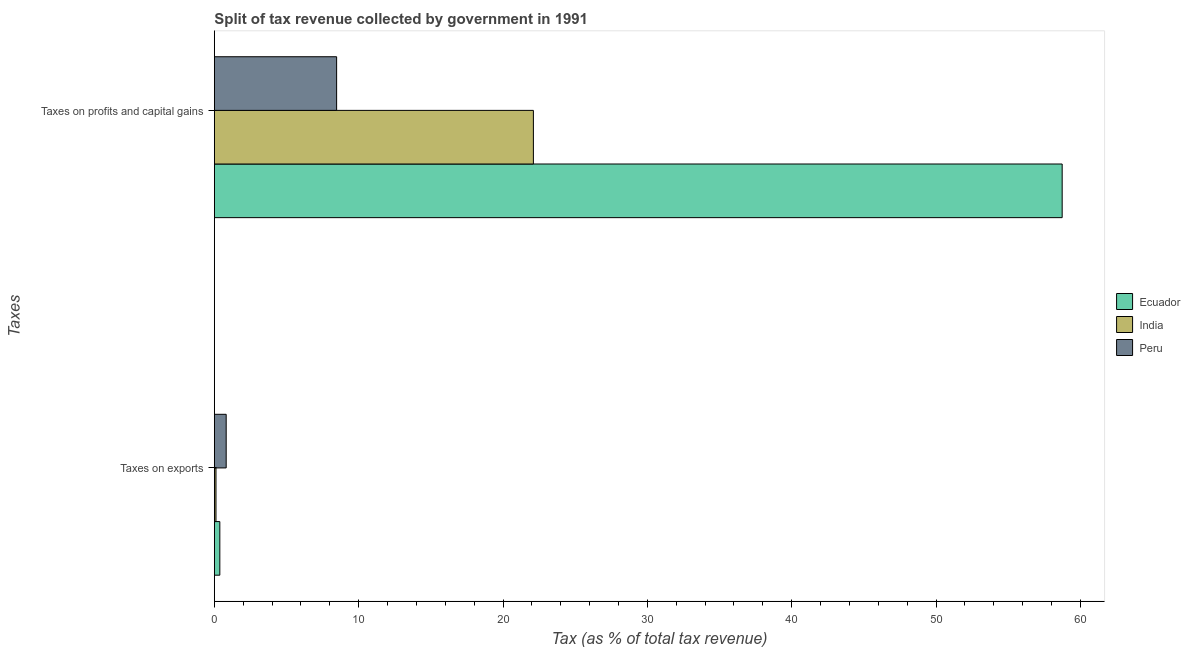How many different coloured bars are there?
Make the answer very short. 3. Are the number of bars per tick equal to the number of legend labels?
Make the answer very short. Yes. How many bars are there on the 1st tick from the top?
Keep it short and to the point. 3. What is the label of the 2nd group of bars from the top?
Your answer should be very brief. Taxes on exports. What is the percentage of revenue obtained from taxes on exports in Ecuador?
Offer a terse response. 0.38. Across all countries, what is the maximum percentage of revenue obtained from taxes on profits and capital gains?
Provide a succinct answer. 58.74. Across all countries, what is the minimum percentage of revenue obtained from taxes on profits and capital gains?
Offer a terse response. 8.47. In which country was the percentage of revenue obtained from taxes on profits and capital gains maximum?
Provide a short and direct response. Ecuador. What is the total percentage of revenue obtained from taxes on exports in the graph?
Your answer should be compact. 1.31. What is the difference between the percentage of revenue obtained from taxes on profits and capital gains in Peru and that in Ecuador?
Give a very brief answer. -50.27. What is the difference between the percentage of revenue obtained from taxes on profits and capital gains in Ecuador and the percentage of revenue obtained from taxes on exports in Peru?
Make the answer very short. 57.92. What is the average percentage of revenue obtained from taxes on exports per country?
Make the answer very short. 0.44. What is the difference between the percentage of revenue obtained from taxes on exports and percentage of revenue obtained from taxes on profits and capital gains in India?
Offer a very short reply. -21.99. In how many countries, is the percentage of revenue obtained from taxes on profits and capital gains greater than 30 %?
Provide a short and direct response. 1. What is the ratio of the percentage of revenue obtained from taxes on exports in Ecuador to that in India?
Provide a succinct answer. 3.37. What does the 1st bar from the top in Taxes on exports represents?
Keep it short and to the point. Peru. What does the 3rd bar from the bottom in Taxes on exports represents?
Your response must be concise. Peru. Are all the bars in the graph horizontal?
Provide a short and direct response. Yes. How many countries are there in the graph?
Your response must be concise. 3. Are the values on the major ticks of X-axis written in scientific E-notation?
Offer a terse response. No. Does the graph contain grids?
Your answer should be compact. No. Where does the legend appear in the graph?
Make the answer very short. Center right. How many legend labels are there?
Give a very brief answer. 3. How are the legend labels stacked?
Make the answer very short. Vertical. What is the title of the graph?
Make the answer very short. Split of tax revenue collected by government in 1991. What is the label or title of the X-axis?
Make the answer very short. Tax (as % of total tax revenue). What is the label or title of the Y-axis?
Provide a succinct answer. Taxes. What is the Tax (as % of total tax revenue) of Ecuador in Taxes on exports?
Provide a short and direct response. 0.38. What is the Tax (as % of total tax revenue) of India in Taxes on exports?
Give a very brief answer. 0.11. What is the Tax (as % of total tax revenue) of Peru in Taxes on exports?
Your answer should be very brief. 0.82. What is the Tax (as % of total tax revenue) in Ecuador in Taxes on profits and capital gains?
Keep it short and to the point. 58.74. What is the Tax (as % of total tax revenue) in India in Taxes on profits and capital gains?
Offer a terse response. 22.1. What is the Tax (as % of total tax revenue) of Peru in Taxes on profits and capital gains?
Your response must be concise. 8.47. Across all Taxes, what is the maximum Tax (as % of total tax revenue) in Ecuador?
Offer a terse response. 58.74. Across all Taxes, what is the maximum Tax (as % of total tax revenue) of India?
Ensure brevity in your answer.  22.1. Across all Taxes, what is the maximum Tax (as % of total tax revenue) of Peru?
Offer a terse response. 8.47. Across all Taxes, what is the minimum Tax (as % of total tax revenue) of Ecuador?
Keep it short and to the point. 0.38. Across all Taxes, what is the minimum Tax (as % of total tax revenue) in India?
Your response must be concise. 0.11. Across all Taxes, what is the minimum Tax (as % of total tax revenue) of Peru?
Your response must be concise. 0.82. What is the total Tax (as % of total tax revenue) in Ecuador in the graph?
Make the answer very short. 59.12. What is the total Tax (as % of total tax revenue) of India in the graph?
Make the answer very short. 22.22. What is the total Tax (as % of total tax revenue) in Peru in the graph?
Offer a very short reply. 9.29. What is the difference between the Tax (as % of total tax revenue) in Ecuador in Taxes on exports and that in Taxes on profits and capital gains?
Make the answer very short. -58.36. What is the difference between the Tax (as % of total tax revenue) of India in Taxes on exports and that in Taxes on profits and capital gains?
Your response must be concise. -21.99. What is the difference between the Tax (as % of total tax revenue) in Peru in Taxes on exports and that in Taxes on profits and capital gains?
Give a very brief answer. -7.65. What is the difference between the Tax (as % of total tax revenue) in Ecuador in Taxes on exports and the Tax (as % of total tax revenue) in India in Taxes on profits and capital gains?
Ensure brevity in your answer.  -21.72. What is the difference between the Tax (as % of total tax revenue) of Ecuador in Taxes on exports and the Tax (as % of total tax revenue) of Peru in Taxes on profits and capital gains?
Keep it short and to the point. -8.09. What is the difference between the Tax (as % of total tax revenue) in India in Taxes on exports and the Tax (as % of total tax revenue) in Peru in Taxes on profits and capital gains?
Offer a terse response. -8.36. What is the average Tax (as % of total tax revenue) in Ecuador per Taxes?
Your answer should be compact. 29.56. What is the average Tax (as % of total tax revenue) in India per Taxes?
Give a very brief answer. 11.11. What is the average Tax (as % of total tax revenue) of Peru per Taxes?
Provide a short and direct response. 4.65. What is the difference between the Tax (as % of total tax revenue) of Ecuador and Tax (as % of total tax revenue) of India in Taxes on exports?
Provide a succinct answer. 0.27. What is the difference between the Tax (as % of total tax revenue) of Ecuador and Tax (as % of total tax revenue) of Peru in Taxes on exports?
Offer a terse response. -0.44. What is the difference between the Tax (as % of total tax revenue) in India and Tax (as % of total tax revenue) in Peru in Taxes on exports?
Provide a succinct answer. -0.71. What is the difference between the Tax (as % of total tax revenue) in Ecuador and Tax (as % of total tax revenue) in India in Taxes on profits and capital gains?
Your response must be concise. 36.64. What is the difference between the Tax (as % of total tax revenue) of Ecuador and Tax (as % of total tax revenue) of Peru in Taxes on profits and capital gains?
Your answer should be compact. 50.27. What is the difference between the Tax (as % of total tax revenue) in India and Tax (as % of total tax revenue) in Peru in Taxes on profits and capital gains?
Offer a terse response. 13.63. What is the ratio of the Tax (as % of total tax revenue) of Ecuador in Taxes on exports to that in Taxes on profits and capital gains?
Provide a short and direct response. 0.01. What is the ratio of the Tax (as % of total tax revenue) in India in Taxes on exports to that in Taxes on profits and capital gains?
Provide a short and direct response. 0.01. What is the ratio of the Tax (as % of total tax revenue) in Peru in Taxes on exports to that in Taxes on profits and capital gains?
Offer a very short reply. 0.1. What is the difference between the highest and the second highest Tax (as % of total tax revenue) in Ecuador?
Provide a succinct answer. 58.36. What is the difference between the highest and the second highest Tax (as % of total tax revenue) of India?
Your answer should be very brief. 21.99. What is the difference between the highest and the second highest Tax (as % of total tax revenue) in Peru?
Give a very brief answer. 7.65. What is the difference between the highest and the lowest Tax (as % of total tax revenue) of Ecuador?
Provide a short and direct response. 58.36. What is the difference between the highest and the lowest Tax (as % of total tax revenue) of India?
Your answer should be very brief. 21.99. What is the difference between the highest and the lowest Tax (as % of total tax revenue) of Peru?
Provide a succinct answer. 7.65. 